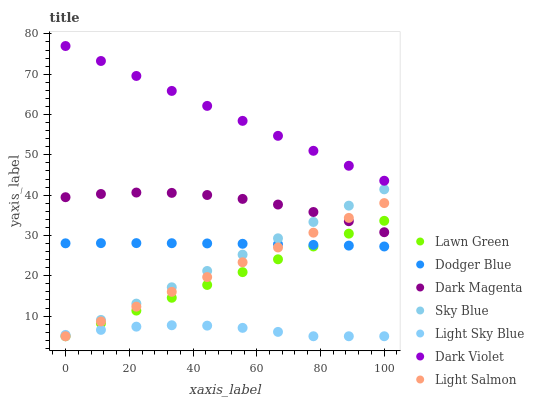Does Light Sky Blue have the minimum area under the curve?
Answer yes or no. Yes. Does Dark Violet have the maximum area under the curve?
Answer yes or no. Yes. Does Light Salmon have the minimum area under the curve?
Answer yes or no. No. Does Light Salmon have the maximum area under the curve?
Answer yes or no. No. Is Lawn Green the smoothest?
Answer yes or no. Yes. Is Dark Magenta the roughest?
Answer yes or no. Yes. Is Light Salmon the smoothest?
Answer yes or no. No. Is Light Salmon the roughest?
Answer yes or no. No. Does Lawn Green have the lowest value?
Answer yes or no. Yes. Does Dark Magenta have the lowest value?
Answer yes or no. No. Does Dark Violet have the highest value?
Answer yes or no. Yes. Does Light Salmon have the highest value?
Answer yes or no. No. Is Light Sky Blue less than Dodger Blue?
Answer yes or no. Yes. Is Dodger Blue greater than Light Sky Blue?
Answer yes or no. Yes. Does Sky Blue intersect Dark Magenta?
Answer yes or no. Yes. Is Sky Blue less than Dark Magenta?
Answer yes or no. No. Is Sky Blue greater than Dark Magenta?
Answer yes or no. No. Does Light Sky Blue intersect Dodger Blue?
Answer yes or no. No. 